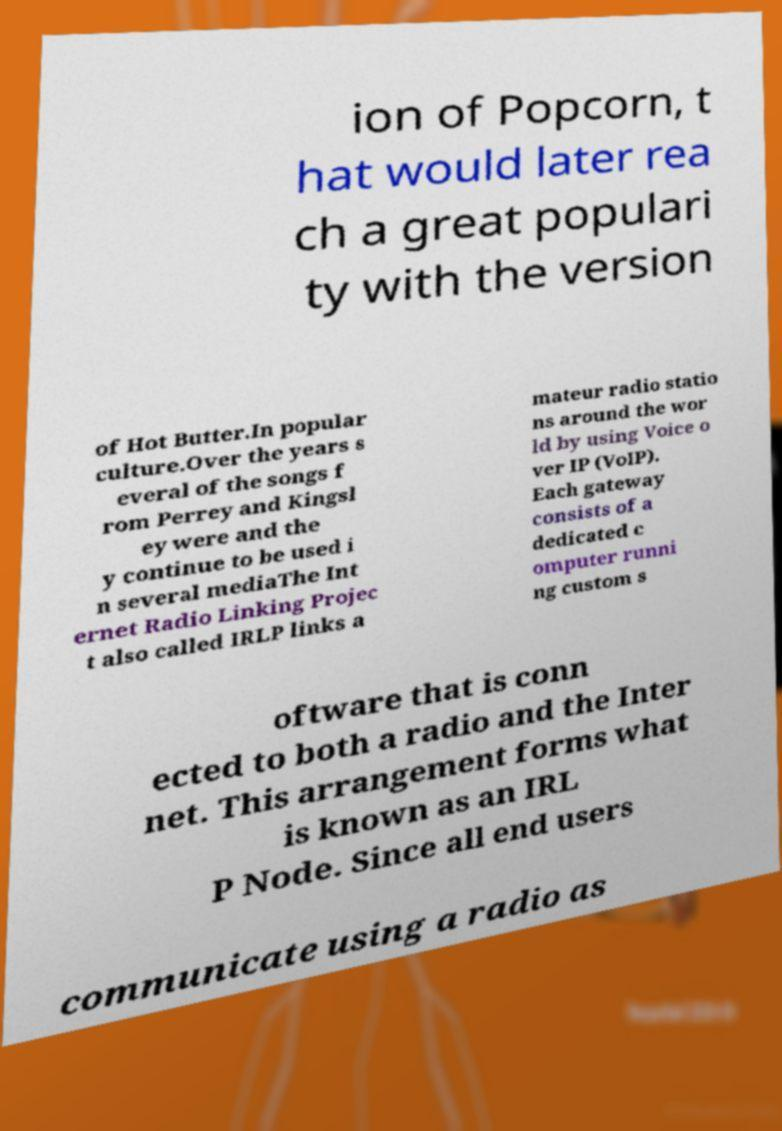For documentation purposes, I need the text within this image transcribed. Could you provide that? ion of Popcorn, t hat would later rea ch a great populari ty with the version of Hot Butter.In popular culture.Over the years s everal of the songs f rom Perrey and Kingsl ey were and the y continue to be used i n several mediaThe Int ernet Radio Linking Projec t also called IRLP links a mateur radio statio ns around the wor ld by using Voice o ver IP (VoIP). Each gateway consists of a dedicated c omputer runni ng custom s oftware that is conn ected to both a radio and the Inter net. This arrangement forms what is known as an IRL P Node. Since all end users communicate using a radio as 